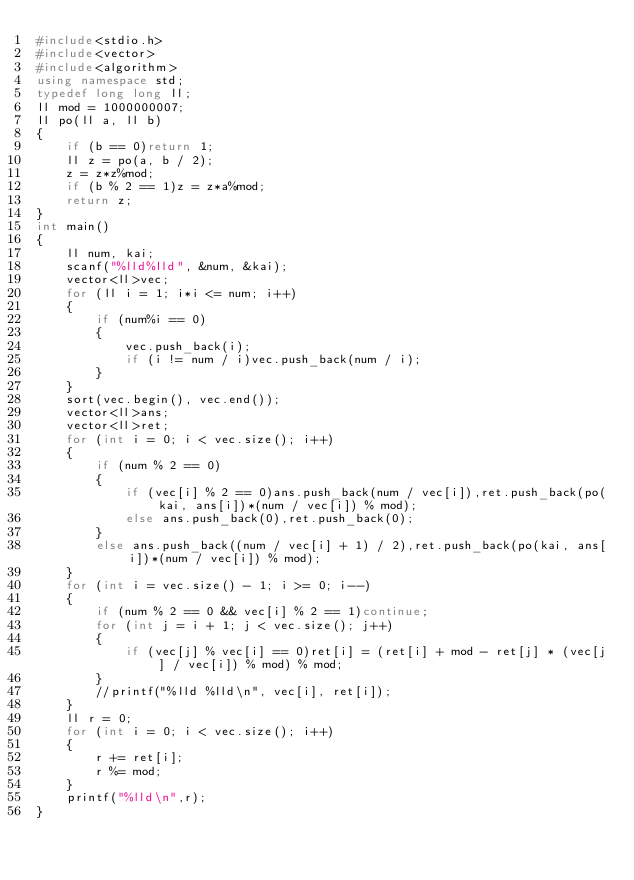Convert code to text. <code><loc_0><loc_0><loc_500><loc_500><_C++_>#include<stdio.h>
#include<vector>
#include<algorithm>
using namespace std;
typedef long long ll;
ll mod = 1000000007;
ll po(ll a, ll b)
{
	if (b == 0)return 1;
	ll z = po(a, b / 2);
	z = z*z%mod;
	if (b % 2 == 1)z = z*a%mod;
	return z;
}
int main()
{
	ll num, kai;
	scanf("%lld%lld", &num, &kai);
	vector<ll>vec;
	for (ll i = 1; i*i <= num; i++)
	{
		if (num%i == 0)
		{
			vec.push_back(i);
			if (i != num / i)vec.push_back(num / i);
		}
	}
	sort(vec.begin(), vec.end());
	vector<ll>ans;
	vector<ll>ret;
	for (int i = 0; i < vec.size(); i++)
	{
		if (num % 2 == 0)
		{
			if (vec[i] % 2 == 0)ans.push_back(num / vec[i]),ret.push_back(po(kai, ans[i])*(num / vec[i]) % mod);
			else ans.push_back(0),ret.push_back(0);
		}
		else ans.push_back((num / vec[i] + 1) / 2),ret.push_back(po(kai, ans[i])*(num / vec[i]) % mod);
	}
	for (int i = vec.size() - 1; i >= 0; i--)
	{
		if (num % 2 == 0 && vec[i] % 2 == 1)continue;
		for (int j = i + 1; j < vec.size(); j++)
		{
			if (vec[j] % vec[i] == 0)ret[i] = (ret[i] + mod - ret[j] * (vec[j] / vec[i]) % mod) % mod;
		}
		//printf("%lld %lld\n", vec[i], ret[i]);
	}
	ll r = 0;
	for (int i = 0; i < vec.size(); i++)
	{
		r += ret[i];
		r %= mod;
	}
	printf("%lld\n",r);
}</code> 